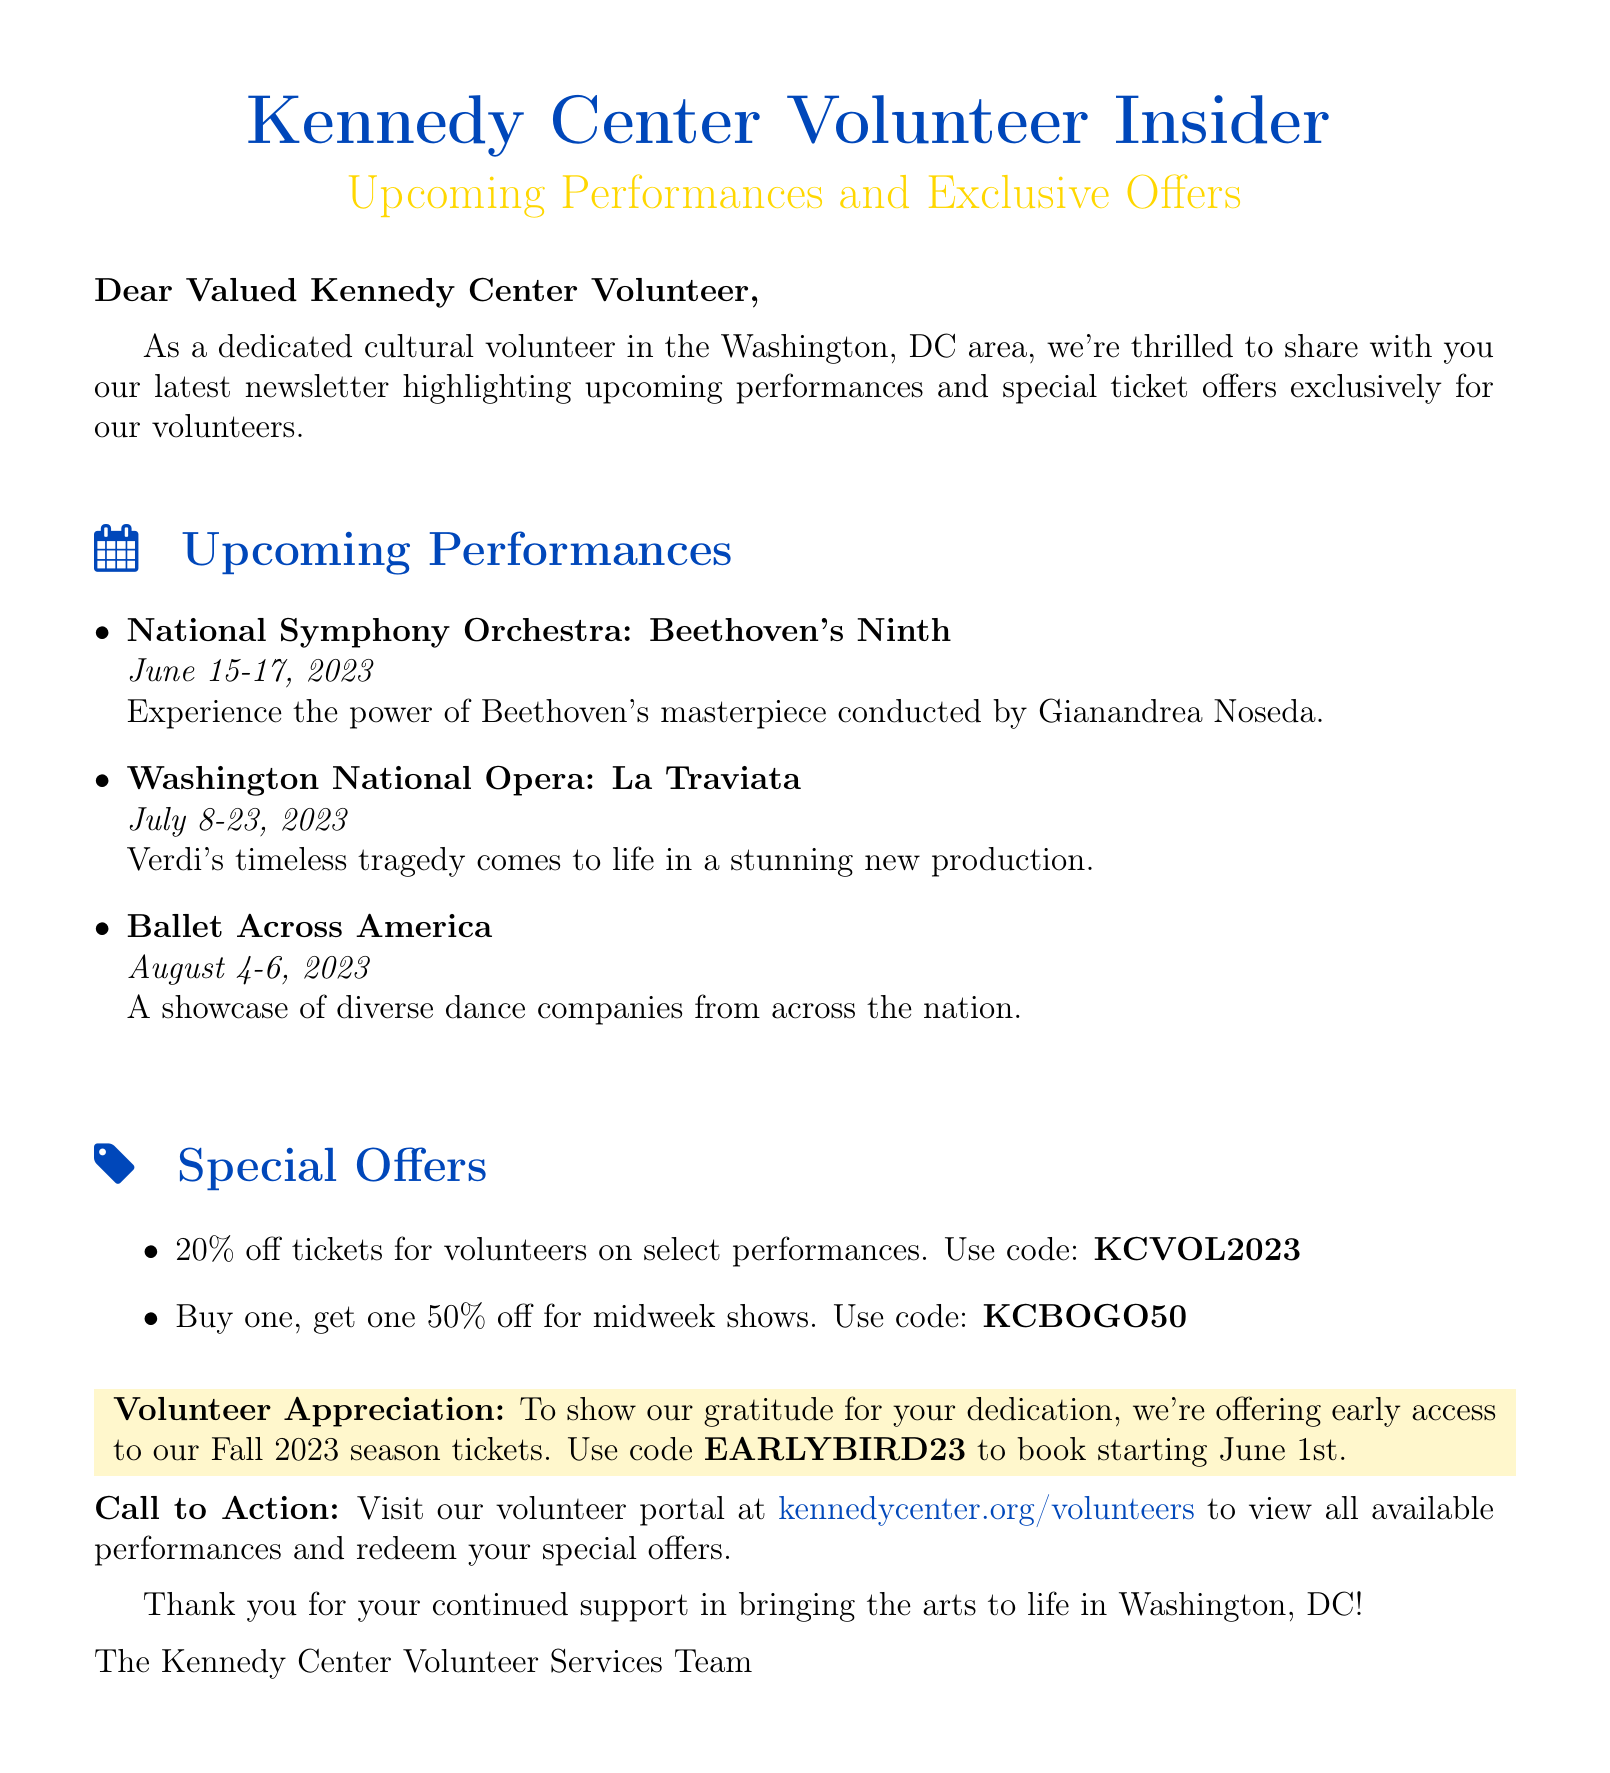What is the title of the first performance? The title of the first performance is listed in the upcoming performances section of the document.
Answer: National Symphony Orchestra: Beethoven's Ninth What are the performance dates for "La Traviata"? The document specifies the performance date range for "La Traviata".
Answer: July 8-23, 2023 What discount code is available for 20% off tickets? The document includes specific codes for taking advantage of special offers for volunteers.
Answer: KCVOL2023 How many performances are listed in total? The total number of performances can be counted from the upcoming performances section of the document.
Answer: 3 What unique offer is provided for early access to Fall 2023 season tickets? The unique offer for early access is specifically mentioned in the document, along with the use of a code.
Answer: EARLYBIRD23 What is the purpose of this newsletter? The overall purpose of the newsletter is indicated in the introduction section of the document.
Answer: Highlight upcoming performances and special ticket offers What type of performances will be showcased in "Ballet Across America"? The document describes the type of showcases that will be featured in "Ballet Across America".
Answer: Diverse dance companies What is the call to action for volunteers? The call to action is a specific request mentioned at the end of the document encouraging volunteers to visit a portal.
Answer: Visit our volunteer portal at kennedycenter.org/volunteers 